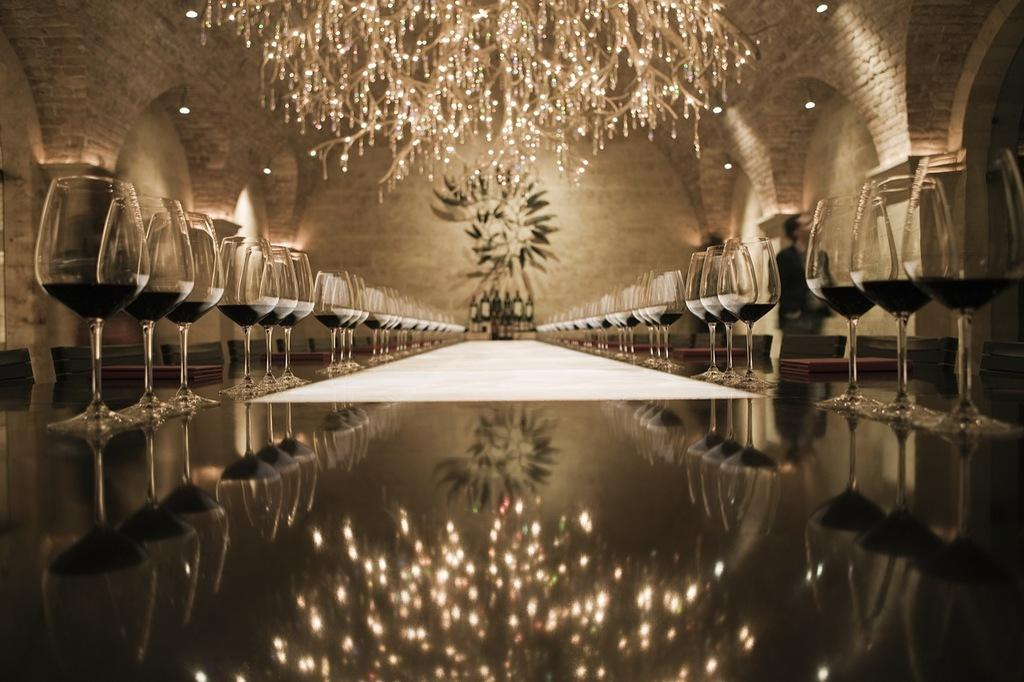What is located in the foreground of the image? There is a table in the foreground of the image. What is placed on the table? Many glasses are placed on the table. What can be seen in the background of the image? There are chairs, a wall, lights, and a chandelier in the background of the image. What type of club is being used to fix the engine in the image? There is no club or engine present in the image; it features a table with glasses and a background with chairs, a wall, lights, and a chandelier. 